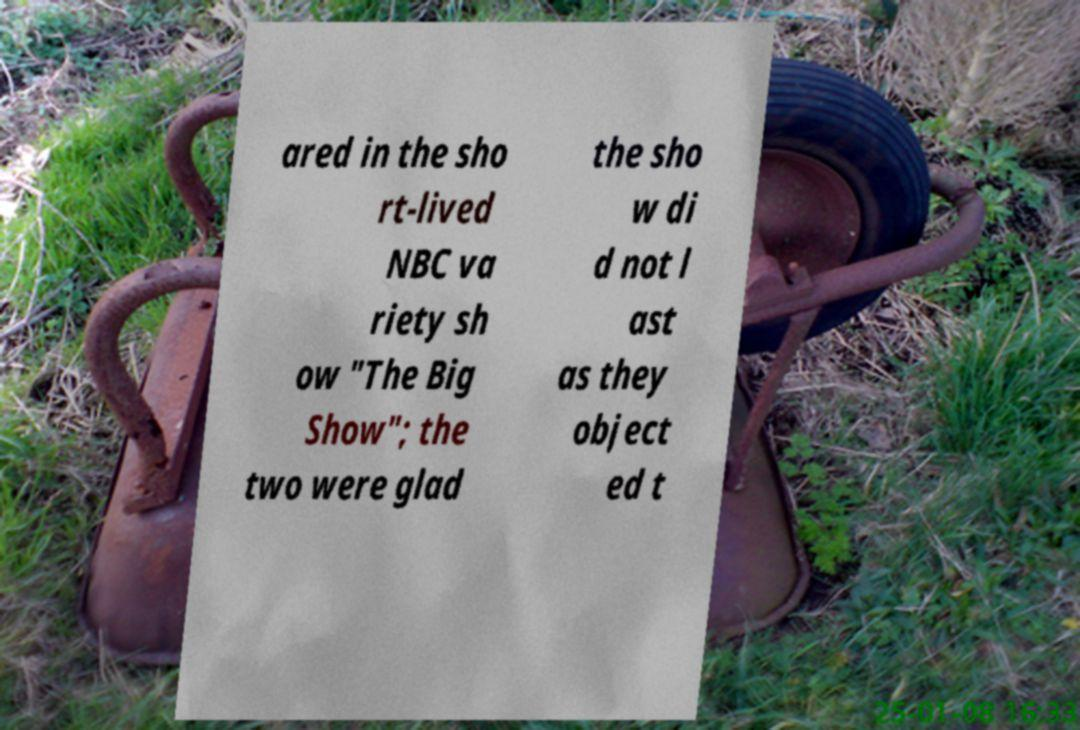Can you read and provide the text displayed in the image?This photo seems to have some interesting text. Can you extract and type it out for me? ared in the sho rt-lived NBC va riety sh ow "The Big Show"; the two were glad the sho w di d not l ast as they object ed t 